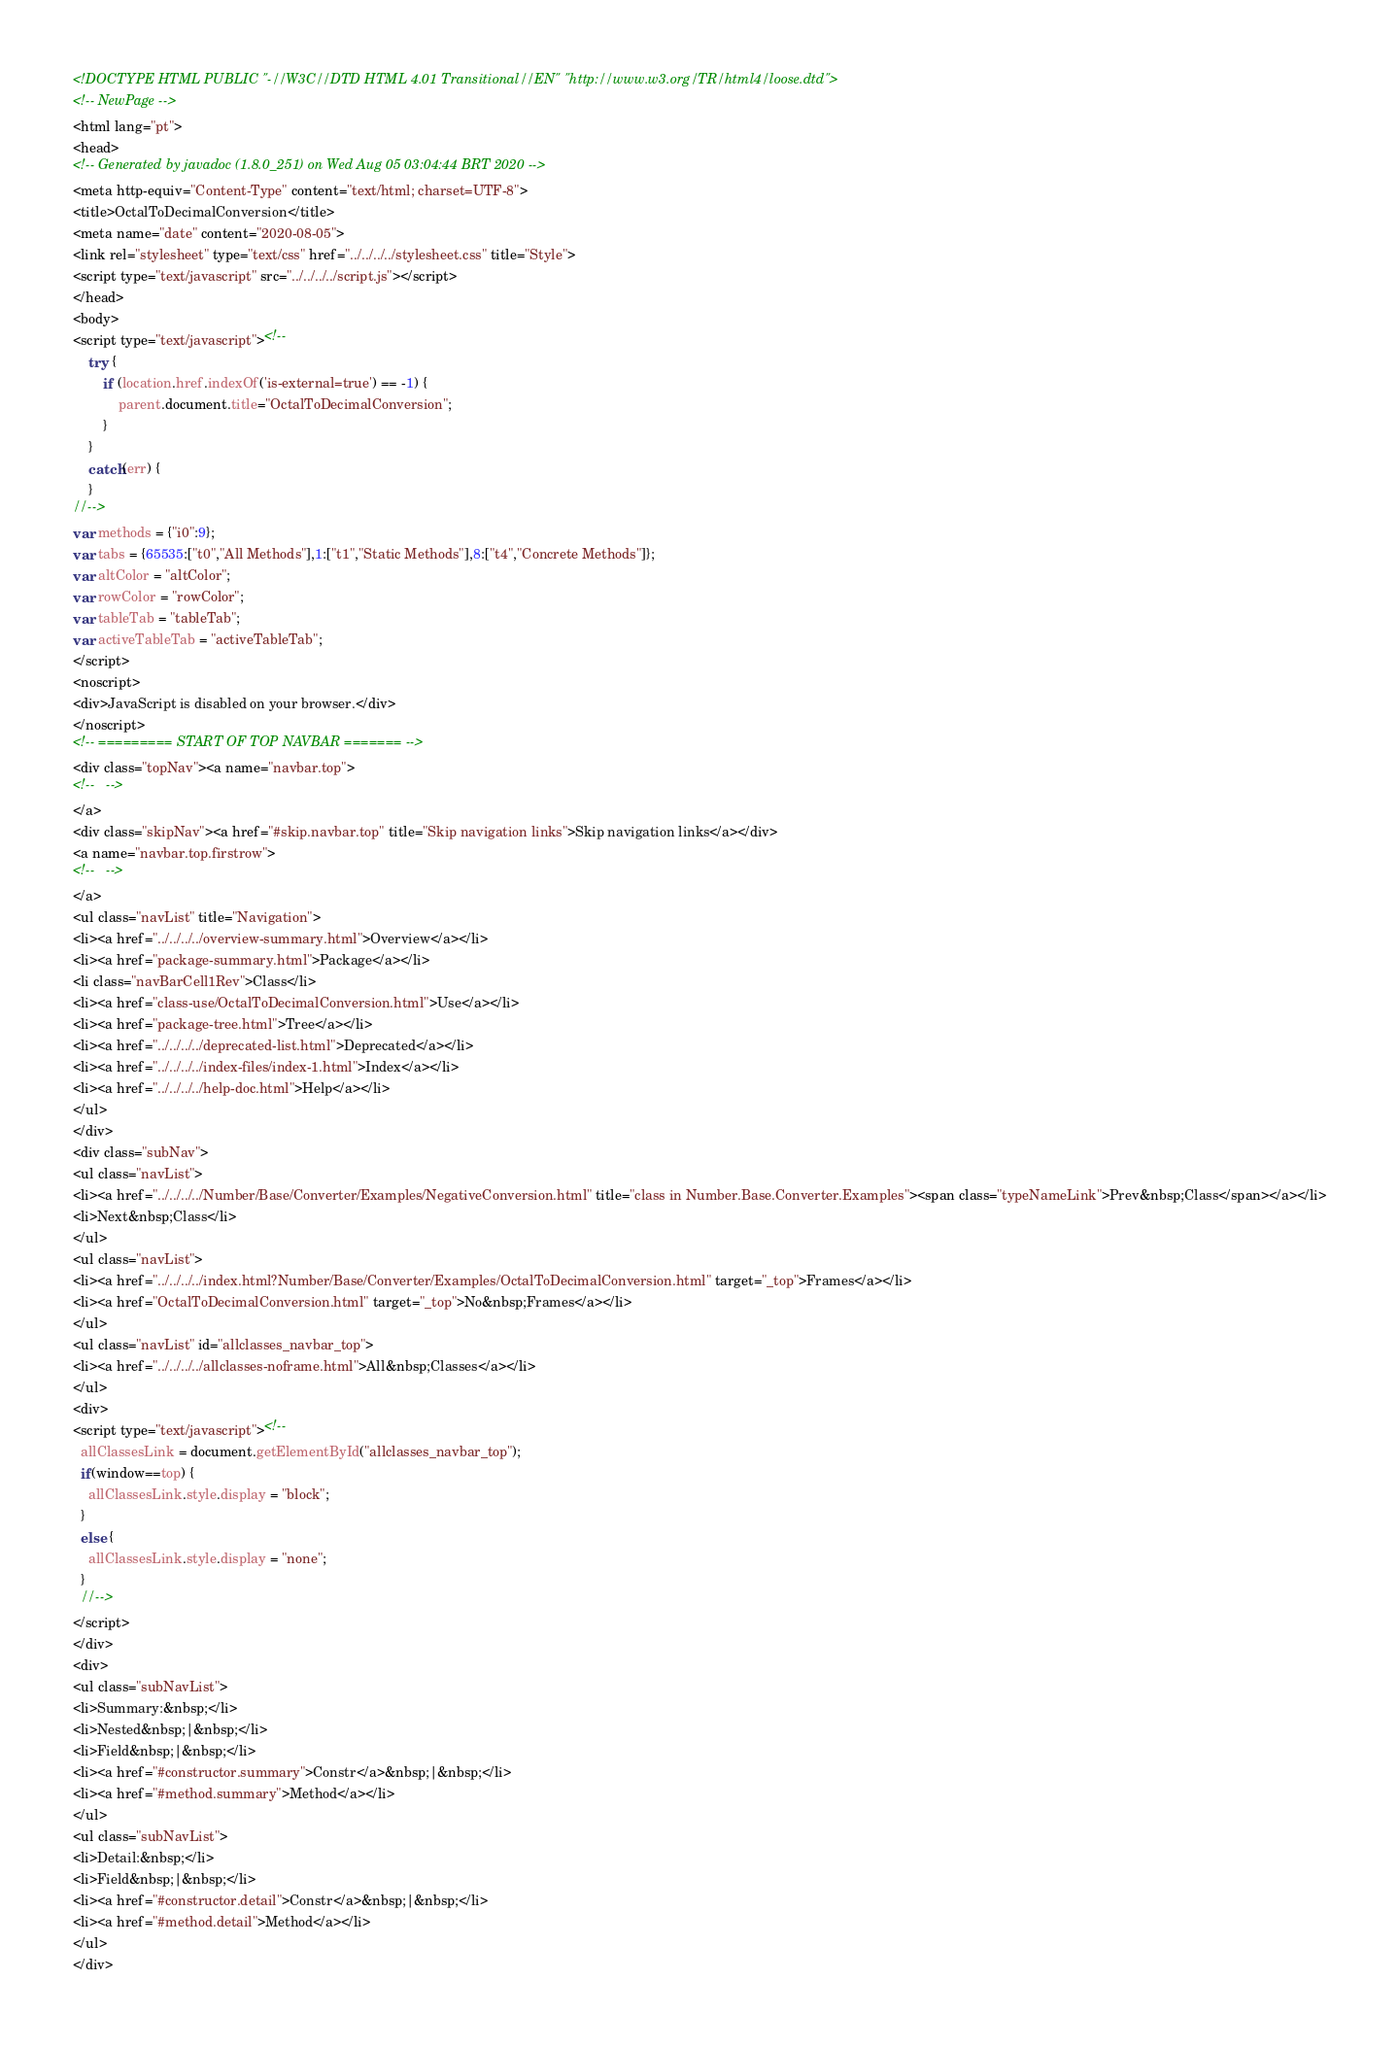Convert code to text. <code><loc_0><loc_0><loc_500><loc_500><_HTML_><!DOCTYPE HTML PUBLIC "-//W3C//DTD HTML 4.01 Transitional//EN" "http://www.w3.org/TR/html4/loose.dtd">
<!-- NewPage -->
<html lang="pt">
<head>
<!-- Generated by javadoc (1.8.0_251) on Wed Aug 05 03:04:44 BRT 2020 -->
<meta http-equiv="Content-Type" content="text/html; charset=UTF-8">
<title>OctalToDecimalConversion</title>
<meta name="date" content="2020-08-05">
<link rel="stylesheet" type="text/css" href="../../../../stylesheet.css" title="Style">
<script type="text/javascript" src="../../../../script.js"></script>
</head>
<body>
<script type="text/javascript"><!--
    try {
        if (location.href.indexOf('is-external=true') == -1) {
            parent.document.title="OctalToDecimalConversion";
        }
    }
    catch(err) {
    }
//-->
var methods = {"i0":9};
var tabs = {65535:["t0","All Methods"],1:["t1","Static Methods"],8:["t4","Concrete Methods"]};
var altColor = "altColor";
var rowColor = "rowColor";
var tableTab = "tableTab";
var activeTableTab = "activeTableTab";
</script>
<noscript>
<div>JavaScript is disabled on your browser.</div>
</noscript>
<!-- ========= START OF TOP NAVBAR ======= -->
<div class="topNav"><a name="navbar.top">
<!--   -->
</a>
<div class="skipNav"><a href="#skip.navbar.top" title="Skip navigation links">Skip navigation links</a></div>
<a name="navbar.top.firstrow">
<!--   -->
</a>
<ul class="navList" title="Navigation">
<li><a href="../../../../overview-summary.html">Overview</a></li>
<li><a href="package-summary.html">Package</a></li>
<li class="navBarCell1Rev">Class</li>
<li><a href="class-use/OctalToDecimalConversion.html">Use</a></li>
<li><a href="package-tree.html">Tree</a></li>
<li><a href="../../../../deprecated-list.html">Deprecated</a></li>
<li><a href="../../../../index-files/index-1.html">Index</a></li>
<li><a href="../../../../help-doc.html">Help</a></li>
</ul>
</div>
<div class="subNav">
<ul class="navList">
<li><a href="../../../../Number/Base/Converter/Examples/NegativeConversion.html" title="class in Number.Base.Converter.Examples"><span class="typeNameLink">Prev&nbsp;Class</span></a></li>
<li>Next&nbsp;Class</li>
</ul>
<ul class="navList">
<li><a href="../../../../index.html?Number/Base/Converter/Examples/OctalToDecimalConversion.html" target="_top">Frames</a></li>
<li><a href="OctalToDecimalConversion.html" target="_top">No&nbsp;Frames</a></li>
</ul>
<ul class="navList" id="allclasses_navbar_top">
<li><a href="../../../../allclasses-noframe.html">All&nbsp;Classes</a></li>
</ul>
<div>
<script type="text/javascript"><!--
  allClassesLink = document.getElementById("allclasses_navbar_top");
  if(window==top) {
    allClassesLink.style.display = "block";
  }
  else {
    allClassesLink.style.display = "none";
  }
  //-->
</script>
</div>
<div>
<ul class="subNavList">
<li>Summary:&nbsp;</li>
<li>Nested&nbsp;|&nbsp;</li>
<li>Field&nbsp;|&nbsp;</li>
<li><a href="#constructor.summary">Constr</a>&nbsp;|&nbsp;</li>
<li><a href="#method.summary">Method</a></li>
</ul>
<ul class="subNavList">
<li>Detail:&nbsp;</li>
<li>Field&nbsp;|&nbsp;</li>
<li><a href="#constructor.detail">Constr</a>&nbsp;|&nbsp;</li>
<li><a href="#method.detail">Method</a></li>
</ul>
</div></code> 